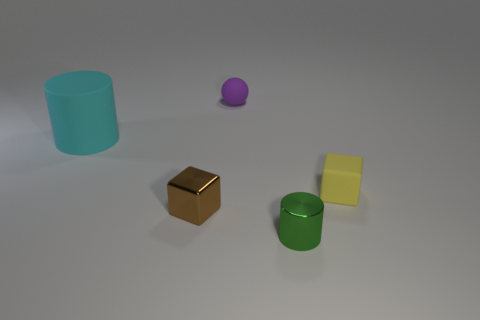Add 1 brown metal objects. How many objects exist? 6 Subtract all cylinders. How many objects are left? 3 Add 4 cyan things. How many cyan things exist? 5 Subtract 1 purple balls. How many objects are left? 4 Subtract all tiny red cylinders. Subtract all big cyan matte objects. How many objects are left? 4 Add 2 large rubber cylinders. How many large rubber cylinders are left? 3 